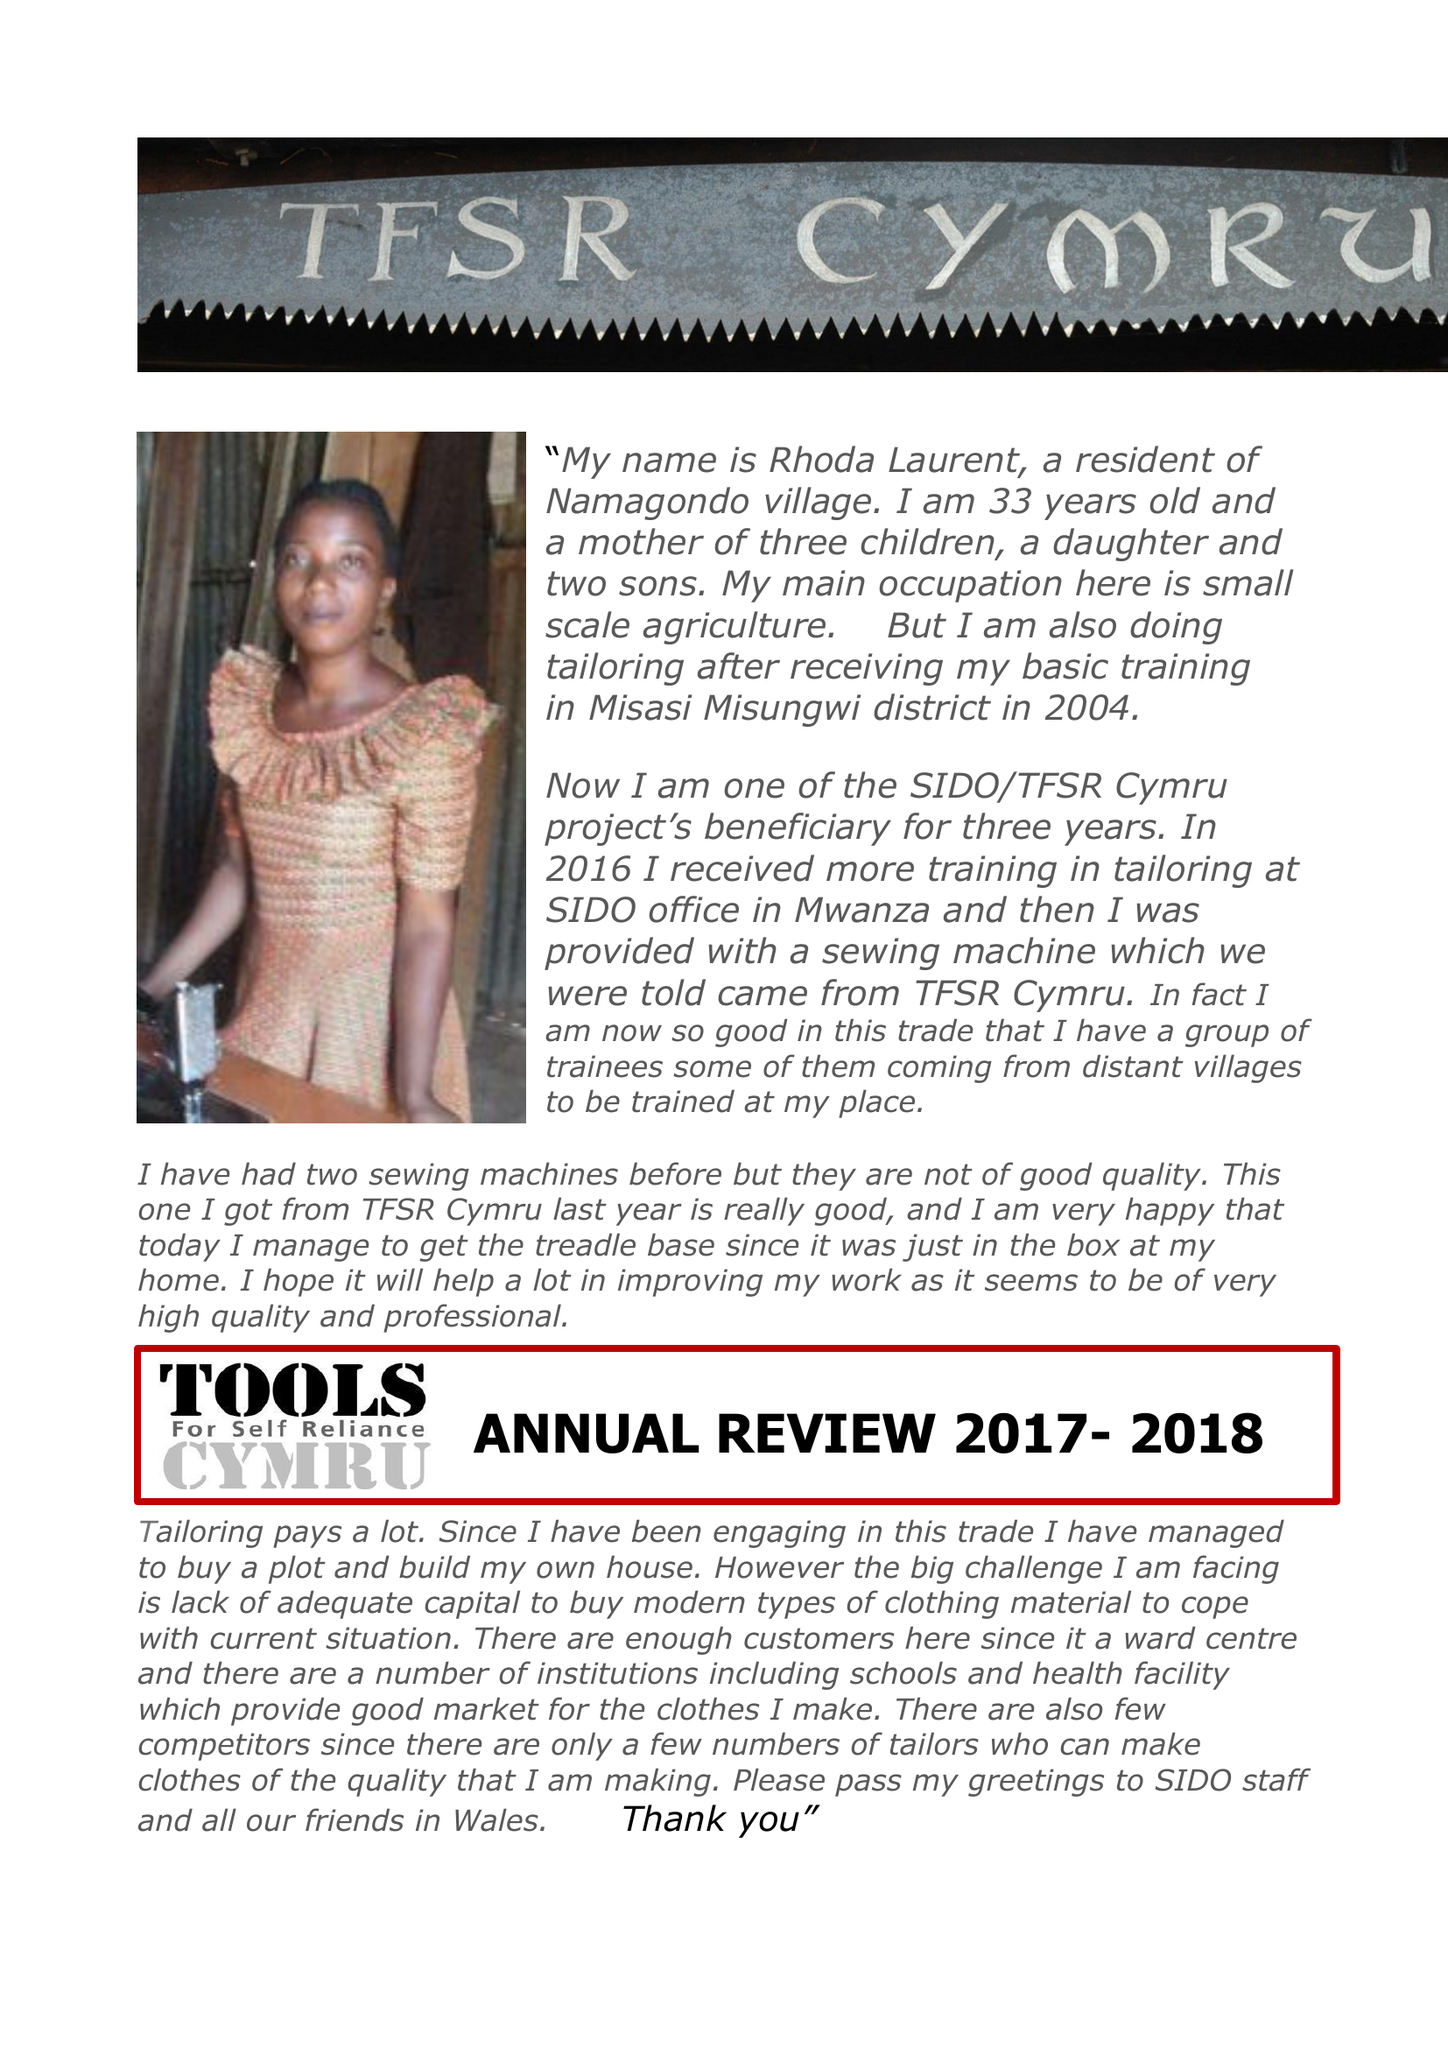What is the value for the charity_number?
Answer the question using a single word or phrase. 1055483 